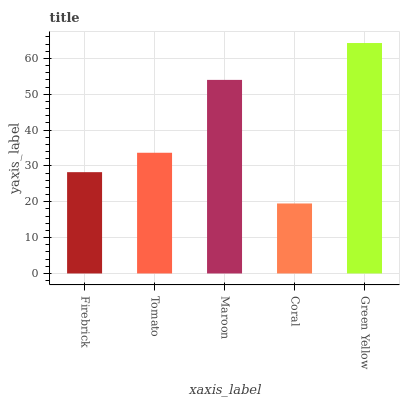Is Coral the minimum?
Answer yes or no. Yes. Is Green Yellow the maximum?
Answer yes or no. Yes. Is Tomato the minimum?
Answer yes or no. No. Is Tomato the maximum?
Answer yes or no. No. Is Tomato greater than Firebrick?
Answer yes or no. Yes. Is Firebrick less than Tomato?
Answer yes or no. Yes. Is Firebrick greater than Tomato?
Answer yes or no. No. Is Tomato less than Firebrick?
Answer yes or no. No. Is Tomato the high median?
Answer yes or no. Yes. Is Tomato the low median?
Answer yes or no. Yes. Is Maroon the high median?
Answer yes or no. No. Is Coral the low median?
Answer yes or no. No. 